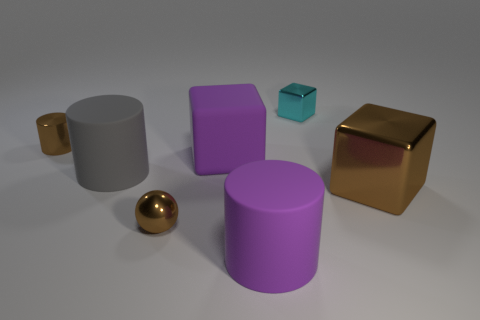There is a tiny thing that is the same color as the metallic ball; what is its material?
Offer a terse response. Metal. How many other objects are the same color as the rubber block?
Give a very brief answer. 1. What material is the big purple cube?
Offer a terse response. Rubber. What number of other things are made of the same material as the large gray cylinder?
Keep it short and to the point. 2. There is a metal thing that is both in front of the small brown metal cylinder and to the left of the cyan metal block; what is its size?
Offer a terse response. Small. What is the shape of the big object on the right side of the big rubber object to the right of the large purple block?
Provide a short and direct response. Cube. Are there any other things that are the same shape as the gray object?
Your response must be concise. Yes. Are there an equal number of big purple matte blocks that are to the left of the small brown metallic sphere and big matte cubes?
Offer a very short reply. No. Do the big rubber block and the block that is on the right side of the cyan metal object have the same color?
Offer a terse response. No. The small metal thing that is to the right of the small metal cylinder and on the left side of the tiny metallic block is what color?
Offer a very short reply. Brown. 